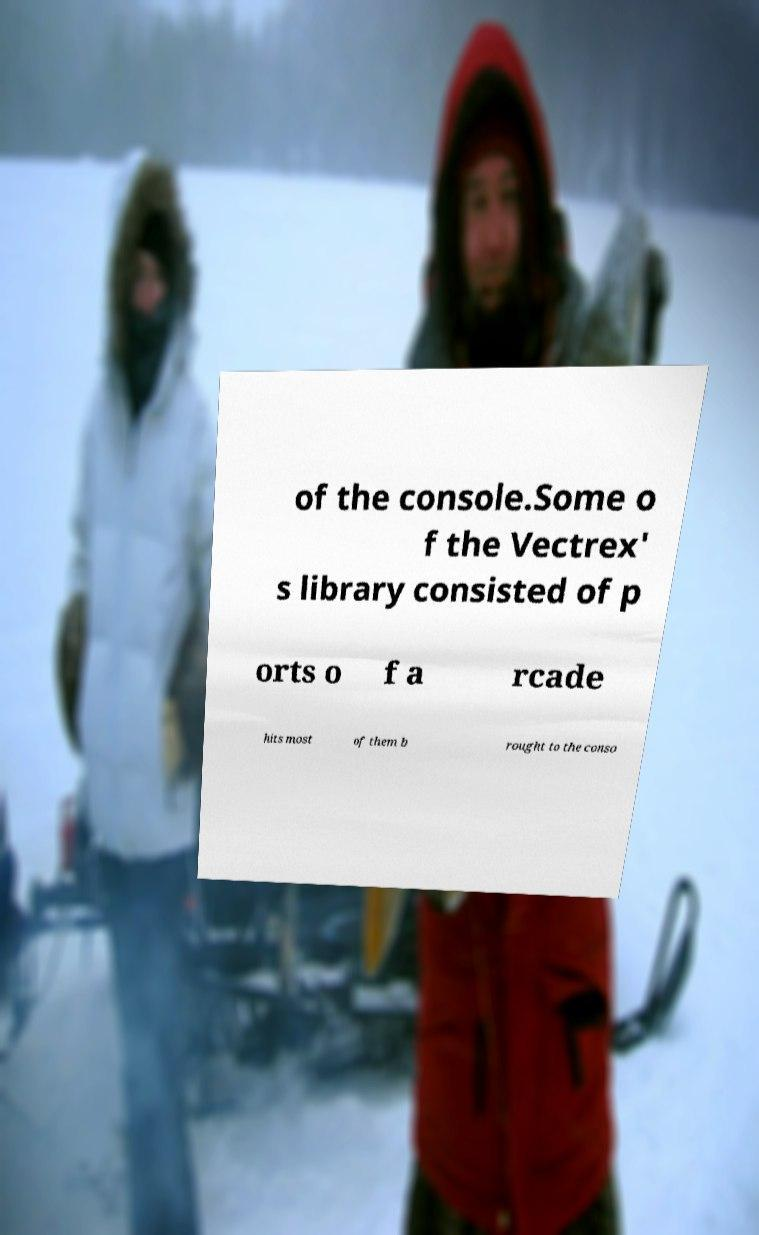Please identify and transcribe the text found in this image. of the console.Some o f the Vectrex' s library consisted of p orts o f a rcade hits most of them b rought to the conso 